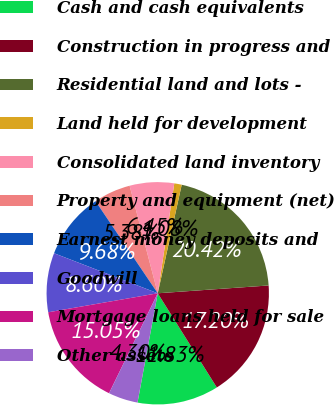Convert chart to OTSL. <chart><loc_0><loc_0><loc_500><loc_500><pie_chart><fcel>Cash and cash equivalents<fcel>Construction in progress and<fcel>Residential land and lots -<fcel>Land held for development<fcel>Consolidated land inventory<fcel>Property and equipment (net)<fcel>Earnest money deposits and<fcel>Goodwill<fcel>Mortgage loans held for sale<fcel>Other assets<nl><fcel>11.83%<fcel>17.2%<fcel>20.42%<fcel>1.08%<fcel>6.45%<fcel>5.38%<fcel>9.68%<fcel>8.6%<fcel>15.05%<fcel>4.3%<nl></chart> 